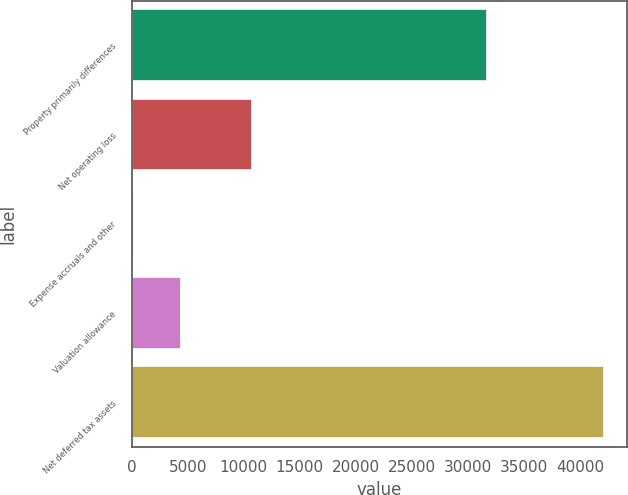Convert chart. <chart><loc_0><loc_0><loc_500><loc_500><bar_chart><fcel>Property primarily differences<fcel>Net operating loss<fcel>Expense accruals and other<fcel>Valuation allowance<fcel>Net deferred tax assets<nl><fcel>31691<fcel>10720<fcel>229<fcel>4415.3<fcel>42092<nl></chart> 